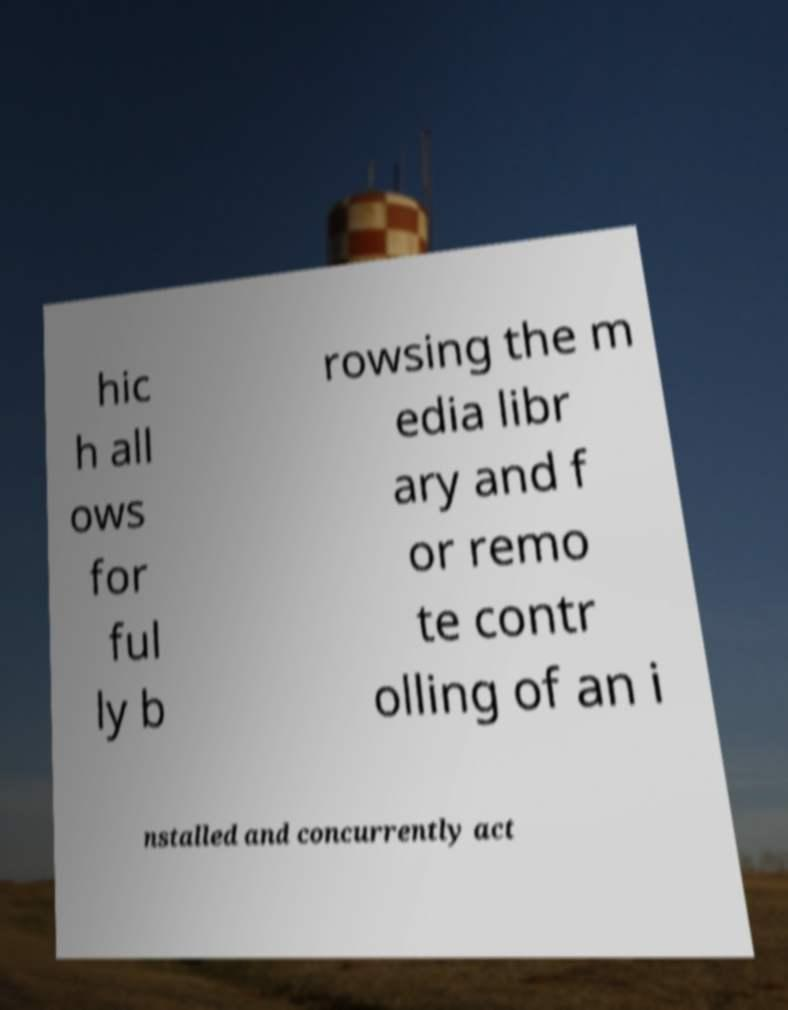Could you extract and type out the text from this image? hic h all ows for ful ly b rowsing the m edia libr ary and f or remo te contr olling of an i nstalled and concurrently act 